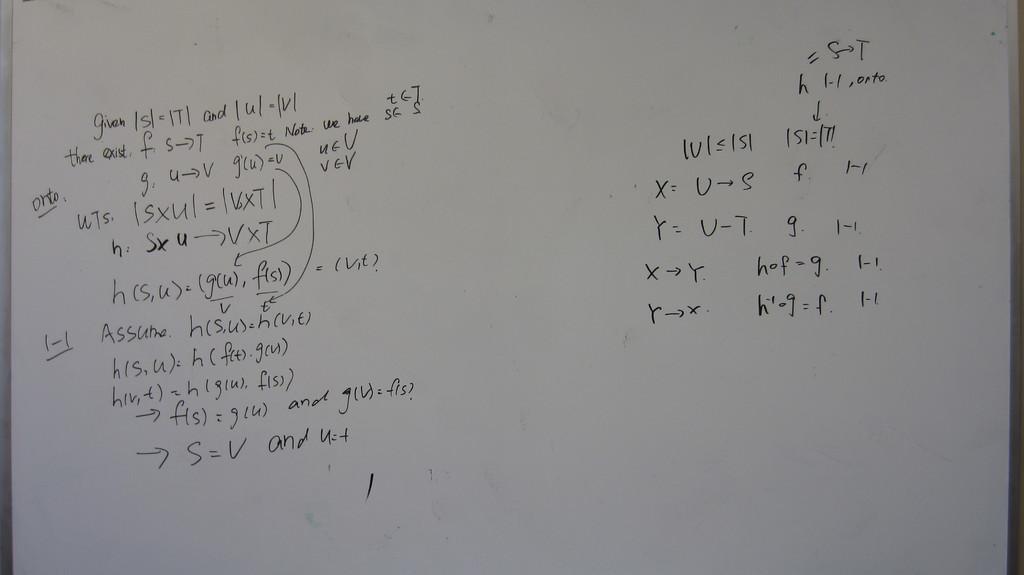What equation is on the bottom left column?
Provide a short and direct response. S=v and u=t. 